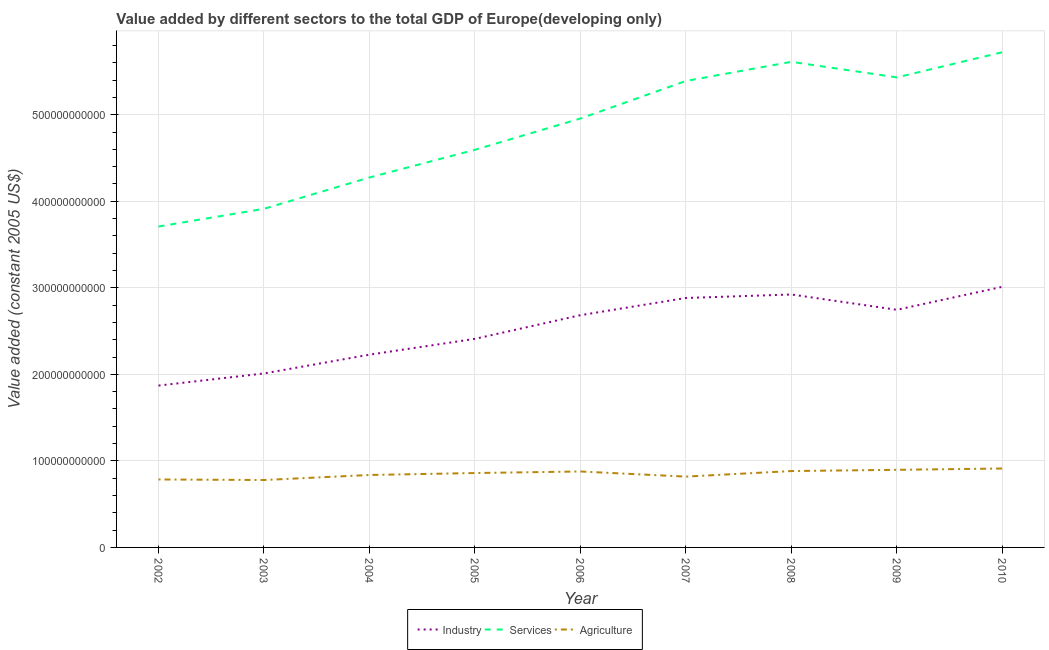How many different coloured lines are there?
Offer a terse response. 3. Is the number of lines equal to the number of legend labels?
Your answer should be compact. Yes. What is the value added by industrial sector in 2010?
Keep it short and to the point. 3.01e+11. Across all years, what is the maximum value added by agricultural sector?
Provide a short and direct response. 9.12e+1. Across all years, what is the minimum value added by services?
Your response must be concise. 3.71e+11. What is the total value added by services in the graph?
Offer a very short reply. 4.36e+12. What is the difference between the value added by industrial sector in 2006 and that in 2010?
Your answer should be compact. -3.28e+1. What is the difference between the value added by industrial sector in 2010 and the value added by services in 2007?
Make the answer very short. -2.38e+11. What is the average value added by agricultural sector per year?
Your response must be concise. 8.50e+1. In the year 2008, what is the difference between the value added by services and value added by agricultural sector?
Your answer should be very brief. 4.73e+11. What is the ratio of the value added by agricultural sector in 2008 to that in 2009?
Make the answer very short. 0.98. Is the difference between the value added by services in 2003 and 2009 greater than the difference between the value added by industrial sector in 2003 and 2009?
Your answer should be compact. No. What is the difference between the highest and the second highest value added by industrial sector?
Ensure brevity in your answer.  8.87e+09. What is the difference between the highest and the lowest value added by industrial sector?
Your answer should be very brief. 1.14e+11. In how many years, is the value added by industrial sector greater than the average value added by industrial sector taken over all years?
Give a very brief answer. 5. Is it the case that in every year, the sum of the value added by industrial sector and value added by services is greater than the value added by agricultural sector?
Give a very brief answer. Yes. Does the value added by services monotonically increase over the years?
Your answer should be compact. No. How many lines are there?
Ensure brevity in your answer.  3. How many years are there in the graph?
Keep it short and to the point. 9. What is the difference between two consecutive major ticks on the Y-axis?
Make the answer very short. 1.00e+11. Where does the legend appear in the graph?
Your answer should be very brief. Bottom center. What is the title of the graph?
Provide a succinct answer. Value added by different sectors to the total GDP of Europe(developing only). What is the label or title of the Y-axis?
Ensure brevity in your answer.  Value added (constant 2005 US$). What is the Value added (constant 2005 US$) of Industry in 2002?
Provide a succinct answer. 1.87e+11. What is the Value added (constant 2005 US$) of Services in 2002?
Keep it short and to the point. 3.71e+11. What is the Value added (constant 2005 US$) in Agriculture in 2002?
Provide a succinct answer. 7.85e+1. What is the Value added (constant 2005 US$) of Industry in 2003?
Your response must be concise. 2.01e+11. What is the Value added (constant 2005 US$) of Services in 2003?
Ensure brevity in your answer.  3.91e+11. What is the Value added (constant 2005 US$) in Agriculture in 2003?
Your answer should be compact. 7.79e+1. What is the Value added (constant 2005 US$) of Industry in 2004?
Your response must be concise. 2.23e+11. What is the Value added (constant 2005 US$) in Services in 2004?
Give a very brief answer. 4.27e+11. What is the Value added (constant 2005 US$) of Agriculture in 2004?
Provide a short and direct response. 8.37e+1. What is the Value added (constant 2005 US$) of Industry in 2005?
Your response must be concise. 2.41e+11. What is the Value added (constant 2005 US$) of Services in 2005?
Provide a short and direct response. 4.59e+11. What is the Value added (constant 2005 US$) in Agriculture in 2005?
Provide a short and direct response. 8.59e+1. What is the Value added (constant 2005 US$) in Industry in 2006?
Ensure brevity in your answer.  2.68e+11. What is the Value added (constant 2005 US$) in Services in 2006?
Ensure brevity in your answer.  4.96e+11. What is the Value added (constant 2005 US$) of Agriculture in 2006?
Your answer should be compact. 8.78e+1. What is the Value added (constant 2005 US$) in Industry in 2007?
Offer a very short reply. 2.88e+11. What is the Value added (constant 2005 US$) in Services in 2007?
Keep it short and to the point. 5.39e+11. What is the Value added (constant 2005 US$) of Agriculture in 2007?
Make the answer very short. 8.18e+1. What is the Value added (constant 2005 US$) in Industry in 2008?
Provide a succinct answer. 2.92e+11. What is the Value added (constant 2005 US$) of Services in 2008?
Keep it short and to the point. 5.61e+11. What is the Value added (constant 2005 US$) of Agriculture in 2008?
Provide a short and direct response. 8.83e+1. What is the Value added (constant 2005 US$) in Industry in 2009?
Give a very brief answer. 2.75e+11. What is the Value added (constant 2005 US$) of Services in 2009?
Ensure brevity in your answer.  5.43e+11. What is the Value added (constant 2005 US$) of Agriculture in 2009?
Ensure brevity in your answer.  8.97e+1. What is the Value added (constant 2005 US$) in Industry in 2010?
Give a very brief answer. 3.01e+11. What is the Value added (constant 2005 US$) in Services in 2010?
Offer a very short reply. 5.72e+11. What is the Value added (constant 2005 US$) in Agriculture in 2010?
Keep it short and to the point. 9.12e+1. Across all years, what is the maximum Value added (constant 2005 US$) in Industry?
Offer a very short reply. 3.01e+11. Across all years, what is the maximum Value added (constant 2005 US$) of Services?
Keep it short and to the point. 5.72e+11. Across all years, what is the maximum Value added (constant 2005 US$) in Agriculture?
Offer a terse response. 9.12e+1. Across all years, what is the minimum Value added (constant 2005 US$) in Industry?
Give a very brief answer. 1.87e+11. Across all years, what is the minimum Value added (constant 2005 US$) in Services?
Provide a short and direct response. 3.71e+11. Across all years, what is the minimum Value added (constant 2005 US$) of Agriculture?
Offer a terse response. 7.79e+1. What is the total Value added (constant 2005 US$) in Industry in the graph?
Offer a very short reply. 2.28e+12. What is the total Value added (constant 2005 US$) of Services in the graph?
Your response must be concise. 4.36e+12. What is the total Value added (constant 2005 US$) in Agriculture in the graph?
Offer a terse response. 7.65e+11. What is the difference between the Value added (constant 2005 US$) in Industry in 2002 and that in 2003?
Ensure brevity in your answer.  -1.40e+1. What is the difference between the Value added (constant 2005 US$) of Services in 2002 and that in 2003?
Ensure brevity in your answer.  -2.05e+1. What is the difference between the Value added (constant 2005 US$) in Agriculture in 2002 and that in 2003?
Offer a terse response. 6.42e+08. What is the difference between the Value added (constant 2005 US$) of Industry in 2002 and that in 2004?
Your answer should be very brief. -3.57e+1. What is the difference between the Value added (constant 2005 US$) of Services in 2002 and that in 2004?
Make the answer very short. -5.67e+1. What is the difference between the Value added (constant 2005 US$) in Agriculture in 2002 and that in 2004?
Offer a very short reply. -5.18e+09. What is the difference between the Value added (constant 2005 US$) in Industry in 2002 and that in 2005?
Provide a short and direct response. -5.40e+1. What is the difference between the Value added (constant 2005 US$) in Services in 2002 and that in 2005?
Give a very brief answer. -8.86e+1. What is the difference between the Value added (constant 2005 US$) of Agriculture in 2002 and that in 2005?
Make the answer very short. -7.42e+09. What is the difference between the Value added (constant 2005 US$) in Industry in 2002 and that in 2006?
Keep it short and to the point. -8.13e+1. What is the difference between the Value added (constant 2005 US$) in Services in 2002 and that in 2006?
Make the answer very short. -1.25e+11. What is the difference between the Value added (constant 2005 US$) of Agriculture in 2002 and that in 2006?
Make the answer very short. -9.23e+09. What is the difference between the Value added (constant 2005 US$) of Industry in 2002 and that in 2007?
Provide a succinct answer. -1.01e+11. What is the difference between the Value added (constant 2005 US$) of Services in 2002 and that in 2007?
Your answer should be very brief. -1.68e+11. What is the difference between the Value added (constant 2005 US$) of Agriculture in 2002 and that in 2007?
Make the answer very short. -3.29e+09. What is the difference between the Value added (constant 2005 US$) in Industry in 2002 and that in 2008?
Make the answer very short. -1.05e+11. What is the difference between the Value added (constant 2005 US$) in Services in 2002 and that in 2008?
Provide a succinct answer. -1.90e+11. What is the difference between the Value added (constant 2005 US$) in Agriculture in 2002 and that in 2008?
Your answer should be compact. -9.73e+09. What is the difference between the Value added (constant 2005 US$) in Industry in 2002 and that in 2009?
Offer a very short reply. -8.76e+1. What is the difference between the Value added (constant 2005 US$) in Services in 2002 and that in 2009?
Make the answer very short. -1.72e+11. What is the difference between the Value added (constant 2005 US$) of Agriculture in 2002 and that in 2009?
Offer a very short reply. -1.11e+1. What is the difference between the Value added (constant 2005 US$) in Industry in 2002 and that in 2010?
Your answer should be very brief. -1.14e+11. What is the difference between the Value added (constant 2005 US$) in Services in 2002 and that in 2010?
Ensure brevity in your answer.  -2.01e+11. What is the difference between the Value added (constant 2005 US$) of Agriculture in 2002 and that in 2010?
Offer a terse response. -1.27e+1. What is the difference between the Value added (constant 2005 US$) of Industry in 2003 and that in 2004?
Make the answer very short. -2.17e+1. What is the difference between the Value added (constant 2005 US$) in Services in 2003 and that in 2004?
Offer a very short reply. -3.62e+1. What is the difference between the Value added (constant 2005 US$) in Agriculture in 2003 and that in 2004?
Provide a short and direct response. -5.82e+09. What is the difference between the Value added (constant 2005 US$) of Industry in 2003 and that in 2005?
Ensure brevity in your answer.  -4.00e+1. What is the difference between the Value added (constant 2005 US$) in Services in 2003 and that in 2005?
Offer a terse response. -6.82e+1. What is the difference between the Value added (constant 2005 US$) in Agriculture in 2003 and that in 2005?
Provide a succinct answer. -8.06e+09. What is the difference between the Value added (constant 2005 US$) of Industry in 2003 and that in 2006?
Your response must be concise. -6.73e+1. What is the difference between the Value added (constant 2005 US$) in Services in 2003 and that in 2006?
Provide a succinct answer. -1.04e+11. What is the difference between the Value added (constant 2005 US$) in Agriculture in 2003 and that in 2006?
Give a very brief answer. -9.87e+09. What is the difference between the Value added (constant 2005 US$) in Industry in 2003 and that in 2007?
Ensure brevity in your answer.  -8.72e+1. What is the difference between the Value added (constant 2005 US$) of Services in 2003 and that in 2007?
Your response must be concise. -1.48e+11. What is the difference between the Value added (constant 2005 US$) in Agriculture in 2003 and that in 2007?
Offer a terse response. -3.93e+09. What is the difference between the Value added (constant 2005 US$) in Industry in 2003 and that in 2008?
Ensure brevity in your answer.  -9.12e+1. What is the difference between the Value added (constant 2005 US$) of Services in 2003 and that in 2008?
Give a very brief answer. -1.70e+11. What is the difference between the Value added (constant 2005 US$) of Agriculture in 2003 and that in 2008?
Offer a very short reply. -1.04e+1. What is the difference between the Value added (constant 2005 US$) in Industry in 2003 and that in 2009?
Your answer should be very brief. -7.35e+1. What is the difference between the Value added (constant 2005 US$) of Services in 2003 and that in 2009?
Make the answer very short. -1.52e+11. What is the difference between the Value added (constant 2005 US$) in Agriculture in 2003 and that in 2009?
Give a very brief answer. -1.18e+1. What is the difference between the Value added (constant 2005 US$) of Industry in 2003 and that in 2010?
Offer a very short reply. -1.00e+11. What is the difference between the Value added (constant 2005 US$) of Services in 2003 and that in 2010?
Ensure brevity in your answer.  -1.81e+11. What is the difference between the Value added (constant 2005 US$) in Agriculture in 2003 and that in 2010?
Offer a very short reply. -1.33e+1. What is the difference between the Value added (constant 2005 US$) in Industry in 2004 and that in 2005?
Give a very brief answer. -1.83e+1. What is the difference between the Value added (constant 2005 US$) in Services in 2004 and that in 2005?
Your response must be concise. -3.20e+1. What is the difference between the Value added (constant 2005 US$) in Agriculture in 2004 and that in 2005?
Provide a short and direct response. -2.24e+09. What is the difference between the Value added (constant 2005 US$) of Industry in 2004 and that in 2006?
Give a very brief answer. -4.56e+1. What is the difference between the Value added (constant 2005 US$) in Services in 2004 and that in 2006?
Your answer should be very brief. -6.81e+1. What is the difference between the Value added (constant 2005 US$) in Agriculture in 2004 and that in 2006?
Make the answer very short. -4.05e+09. What is the difference between the Value added (constant 2005 US$) of Industry in 2004 and that in 2007?
Your response must be concise. -6.55e+1. What is the difference between the Value added (constant 2005 US$) in Services in 2004 and that in 2007?
Give a very brief answer. -1.12e+11. What is the difference between the Value added (constant 2005 US$) in Agriculture in 2004 and that in 2007?
Provide a succinct answer. 1.89e+09. What is the difference between the Value added (constant 2005 US$) of Industry in 2004 and that in 2008?
Your answer should be very brief. -6.95e+1. What is the difference between the Value added (constant 2005 US$) in Services in 2004 and that in 2008?
Give a very brief answer. -1.34e+11. What is the difference between the Value added (constant 2005 US$) in Agriculture in 2004 and that in 2008?
Keep it short and to the point. -4.55e+09. What is the difference between the Value added (constant 2005 US$) of Industry in 2004 and that in 2009?
Offer a terse response. -5.18e+1. What is the difference between the Value added (constant 2005 US$) in Services in 2004 and that in 2009?
Provide a short and direct response. -1.16e+11. What is the difference between the Value added (constant 2005 US$) in Agriculture in 2004 and that in 2009?
Provide a succinct answer. -5.96e+09. What is the difference between the Value added (constant 2005 US$) in Industry in 2004 and that in 2010?
Ensure brevity in your answer.  -7.84e+1. What is the difference between the Value added (constant 2005 US$) in Services in 2004 and that in 2010?
Provide a short and direct response. -1.45e+11. What is the difference between the Value added (constant 2005 US$) in Agriculture in 2004 and that in 2010?
Keep it short and to the point. -7.50e+09. What is the difference between the Value added (constant 2005 US$) in Industry in 2005 and that in 2006?
Your answer should be very brief. -2.74e+1. What is the difference between the Value added (constant 2005 US$) of Services in 2005 and that in 2006?
Your answer should be compact. -3.62e+1. What is the difference between the Value added (constant 2005 US$) of Agriculture in 2005 and that in 2006?
Your response must be concise. -1.81e+09. What is the difference between the Value added (constant 2005 US$) of Industry in 2005 and that in 2007?
Give a very brief answer. -4.72e+1. What is the difference between the Value added (constant 2005 US$) in Services in 2005 and that in 2007?
Offer a terse response. -7.96e+1. What is the difference between the Value added (constant 2005 US$) of Agriculture in 2005 and that in 2007?
Make the answer very short. 4.13e+09. What is the difference between the Value added (constant 2005 US$) of Industry in 2005 and that in 2008?
Ensure brevity in your answer.  -5.13e+1. What is the difference between the Value added (constant 2005 US$) of Services in 2005 and that in 2008?
Provide a succinct answer. -1.02e+11. What is the difference between the Value added (constant 2005 US$) of Agriculture in 2005 and that in 2008?
Make the answer very short. -2.30e+09. What is the difference between the Value added (constant 2005 US$) of Industry in 2005 and that in 2009?
Give a very brief answer. -3.36e+1. What is the difference between the Value added (constant 2005 US$) in Services in 2005 and that in 2009?
Offer a terse response. -8.37e+1. What is the difference between the Value added (constant 2005 US$) of Agriculture in 2005 and that in 2009?
Provide a short and direct response. -3.72e+09. What is the difference between the Value added (constant 2005 US$) in Industry in 2005 and that in 2010?
Keep it short and to the point. -6.01e+1. What is the difference between the Value added (constant 2005 US$) of Services in 2005 and that in 2010?
Provide a succinct answer. -1.13e+11. What is the difference between the Value added (constant 2005 US$) of Agriculture in 2005 and that in 2010?
Offer a terse response. -5.25e+09. What is the difference between the Value added (constant 2005 US$) in Industry in 2006 and that in 2007?
Ensure brevity in your answer.  -1.99e+1. What is the difference between the Value added (constant 2005 US$) of Services in 2006 and that in 2007?
Provide a succinct answer. -4.34e+1. What is the difference between the Value added (constant 2005 US$) in Agriculture in 2006 and that in 2007?
Your response must be concise. 5.94e+09. What is the difference between the Value added (constant 2005 US$) in Industry in 2006 and that in 2008?
Your answer should be compact. -2.39e+1. What is the difference between the Value added (constant 2005 US$) in Services in 2006 and that in 2008?
Give a very brief answer. -6.55e+1. What is the difference between the Value added (constant 2005 US$) in Agriculture in 2006 and that in 2008?
Offer a terse response. -4.99e+08. What is the difference between the Value added (constant 2005 US$) of Industry in 2006 and that in 2009?
Your response must be concise. -6.21e+09. What is the difference between the Value added (constant 2005 US$) of Services in 2006 and that in 2009?
Give a very brief answer. -4.75e+1. What is the difference between the Value added (constant 2005 US$) in Agriculture in 2006 and that in 2009?
Give a very brief answer. -1.91e+09. What is the difference between the Value added (constant 2005 US$) of Industry in 2006 and that in 2010?
Provide a short and direct response. -3.28e+1. What is the difference between the Value added (constant 2005 US$) in Services in 2006 and that in 2010?
Your response must be concise. -7.66e+1. What is the difference between the Value added (constant 2005 US$) of Agriculture in 2006 and that in 2010?
Provide a succinct answer. -3.45e+09. What is the difference between the Value added (constant 2005 US$) in Industry in 2007 and that in 2008?
Ensure brevity in your answer.  -4.03e+09. What is the difference between the Value added (constant 2005 US$) in Services in 2007 and that in 2008?
Make the answer very short. -2.21e+1. What is the difference between the Value added (constant 2005 US$) of Agriculture in 2007 and that in 2008?
Keep it short and to the point. -6.43e+09. What is the difference between the Value added (constant 2005 US$) of Industry in 2007 and that in 2009?
Ensure brevity in your answer.  1.37e+1. What is the difference between the Value added (constant 2005 US$) in Services in 2007 and that in 2009?
Make the answer very short. -4.13e+09. What is the difference between the Value added (constant 2005 US$) of Agriculture in 2007 and that in 2009?
Offer a terse response. -7.85e+09. What is the difference between the Value added (constant 2005 US$) in Industry in 2007 and that in 2010?
Offer a very short reply. -1.29e+1. What is the difference between the Value added (constant 2005 US$) in Services in 2007 and that in 2010?
Offer a terse response. -3.32e+1. What is the difference between the Value added (constant 2005 US$) of Agriculture in 2007 and that in 2010?
Provide a short and direct response. -9.39e+09. What is the difference between the Value added (constant 2005 US$) of Industry in 2008 and that in 2009?
Your answer should be very brief. 1.77e+1. What is the difference between the Value added (constant 2005 US$) in Services in 2008 and that in 2009?
Offer a very short reply. 1.80e+1. What is the difference between the Value added (constant 2005 US$) of Agriculture in 2008 and that in 2009?
Provide a succinct answer. -1.41e+09. What is the difference between the Value added (constant 2005 US$) in Industry in 2008 and that in 2010?
Your answer should be compact. -8.87e+09. What is the difference between the Value added (constant 2005 US$) of Services in 2008 and that in 2010?
Provide a short and direct response. -1.11e+1. What is the difference between the Value added (constant 2005 US$) in Agriculture in 2008 and that in 2010?
Make the answer very short. -2.95e+09. What is the difference between the Value added (constant 2005 US$) of Industry in 2009 and that in 2010?
Give a very brief answer. -2.66e+1. What is the difference between the Value added (constant 2005 US$) in Services in 2009 and that in 2010?
Your answer should be compact. -2.91e+1. What is the difference between the Value added (constant 2005 US$) in Agriculture in 2009 and that in 2010?
Make the answer very short. -1.54e+09. What is the difference between the Value added (constant 2005 US$) in Industry in 2002 and the Value added (constant 2005 US$) in Services in 2003?
Give a very brief answer. -2.04e+11. What is the difference between the Value added (constant 2005 US$) in Industry in 2002 and the Value added (constant 2005 US$) in Agriculture in 2003?
Offer a very short reply. 1.09e+11. What is the difference between the Value added (constant 2005 US$) of Services in 2002 and the Value added (constant 2005 US$) of Agriculture in 2003?
Offer a terse response. 2.93e+11. What is the difference between the Value added (constant 2005 US$) of Industry in 2002 and the Value added (constant 2005 US$) of Services in 2004?
Offer a very short reply. -2.40e+11. What is the difference between the Value added (constant 2005 US$) of Industry in 2002 and the Value added (constant 2005 US$) of Agriculture in 2004?
Your response must be concise. 1.03e+11. What is the difference between the Value added (constant 2005 US$) in Services in 2002 and the Value added (constant 2005 US$) in Agriculture in 2004?
Ensure brevity in your answer.  2.87e+11. What is the difference between the Value added (constant 2005 US$) in Industry in 2002 and the Value added (constant 2005 US$) in Services in 2005?
Your answer should be very brief. -2.72e+11. What is the difference between the Value added (constant 2005 US$) in Industry in 2002 and the Value added (constant 2005 US$) in Agriculture in 2005?
Provide a succinct answer. 1.01e+11. What is the difference between the Value added (constant 2005 US$) of Services in 2002 and the Value added (constant 2005 US$) of Agriculture in 2005?
Provide a short and direct response. 2.85e+11. What is the difference between the Value added (constant 2005 US$) in Industry in 2002 and the Value added (constant 2005 US$) in Services in 2006?
Make the answer very short. -3.09e+11. What is the difference between the Value added (constant 2005 US$) in Industry in 2002 and the Value added (constant 2005 US$) in Agriculture in 2006?
Provide a short and direct response. 9.93e+1. What is the difference between the Value added (constant 2005 US$) of Services in 2002 and the Value added (constant 2005 US$) of Agriculture in 2006?
Offer a terse response. 2.83e+11. What is the difference between the Value added (constant 2005 US$) in Industry in 2002 and the Value added (constant 2005 US$) in Services in 2007?
Provide a succinct answer. -3.52e+11. What is the difference between the Value added (constant 2005 US$) in Industry in 2002 and the Value added (constant 2005 US$) in Agriculture in 2007?
Provide a short and direct response. 1.05e+11. What is the difference between the Value added (constant 2005 US$) of Services in 2002 and the Value added (constant 2005 US$) of Agriculture in 2007?
Ensure brevity in your answer.  2.89e+11. What is the difference between the Value added (constant 2005 US$) of Industry in 2002 and the Value added (constant 2005 US$) of Services in 2008?
Keep it short and to the point. -3.74e+11. What is the difference between the Value added (constant 2005 US$) in Industry in 2002 and the Value added (constant 2005 US$) in Agriculture in 2008?
Keep it short and to the point. 9.88e+1. What is the difference between the Value added (constant 2005 US$) of Services in 2002 and the Value added (constant 2005 US$) of Agriculture in 2008?
Offer a terse response. 2.83e+11. What is the difference between the Value added (constant 2005 US$) in Industry in 2002 and the Value added (constant 2005 US$) in Services in 2009?
Give a very brief answer. -3.56e+11. What is the difference between the Value added (constant 2005 US$) of Industry in 2002 and the Value added (constant 2005 US$) of Agriculture in 2009?
Provide a short and direct response. 9.74e+1. What is the difference between the Value added (constant 2005 US$) in Services in 2002 and the Value added (constant 2005 US$) in Agriculture in 2009?
Your answer should be compact. 2.81e+11. What is the difference between the Value added (constant 2005 US$) in Industry in 2002 and the Value added (constant 2005 US$) in Services in 2010?
Make the answer very short. -3.85e+11. What is the difference between the Value added (constant 2005 US$) in Industry in 2002 and the Value added (constant 2005 US$) in Agriculture in 2010?
Your response must be concise. 9.58e+1. What is the difference between the Value added (constant 2005 US$) in Services in 2002 and the Value added (constant 2005 US$) in Agriculture in 2010?
Ensure brevity in your answer.  2.80e+11. What is the difference between the Value added (constant 2005 US$) in Industry in 2003 and the Value added (constant 2005 US$) in Services in 2004?
Your answer should be compact. -2.26e+11. What is the difference between the Value added (constant 2005 US$) in Industry in 2003 and the Value added (constant 2005 US$) in Agriculture in 2004?
Your answer should be very brief. 1.17e+11. What is the difference between the Value added (constant 2005 US$) of Services in 2003 and the Value added (constant 2005 US$) of Agriculture in 2004?
Provide a short and direct response. 3.08e+11. What is the difference between the Value added (constant 2005 US$) of Industry in 2003 and the Value added (constant 2005 US$) of Services in 2005?
Make the answer very short. -2.58e+11. What is the difference between the Value added (constant 2005 US$) in Industry in 2003 and the Value added (constant 2005 US$) in Agriculture in 2005?
Offer a very short reply. 1.15e+11. What is the difference between the Value added (constant 2005 US$) of Services in 2003 and the Value added (constant 2005 US$) of Agriculture in 2005?
Ensure brevity in your answer.  3.05e+11. What is the difference between the Value added (constant 2005 US$) of Industry in 2003 and the Value added (constant 2005 US$) of Services in 2006?
Provide a succinct answer. -2.95e+11. What is the difference between the Value added (constant 2005 US$) of Industry in 2003 and the Value added (constant 2005 US$) of Agriculture in 2006?
Your answer should be very brief. 1.13e+11. What is the difference between the Value added (constant 2005 US$) of Services in 2003 and the Value added (constant 2005 US$) of Agriculture in 2006?
Give a very brief answer. 3.04e+11. What is the difference between the Value added (constant 2005 US$) of Industry in 2003 and the Value added (constant 2005 US$) of Services in 2007?
Give a very brief answer. -3.38e+11. What is the difference between the Value added (constant 2005 US$) in Industry in 2003 and the Value added (constant 2005 US$) in Agriculture in 2007?
Your response must be concise. 1.19e+11. What is the difference between the Value added (constant 2005 US$) of Services in 2003 and the Value added (constant 2005 US$) of Agriculture in 2007?
Make the answer very short. 3.09e+11. What is the difference between the Value added (constant 2005 US$) in Industry in 2003 and the Value added (constant 2005 US$) in Services in 2008?
Provide a short and direct response. -3.60e+11. What is the difference between the Value added (constant 2005 US$) in Industry in 2003 and the Value added (constant 2005 US$) in Agriculture in 2008?
Ensure brevity in your answer.  1.13e+11. What is the difference between the Value added (constant 2005 US$) in Services in 2003 and the Value added (constant 2005 US$) in Agriculture in 2008?
Keep it short and to the point. 3.03e+11. What is the difference between the Value added (constant 2005 US$) of Industry in 2003 and the Value added (constant 2005 US$) of Services in 2009?
Keep it short and to the point. -3.42e+11. What is the difference between the Value added (constant 2005 US$) in Industry in 2003 and the Value added (constant 2005 US$) in Agriculture in 2009?
Provide a short and direct response. 1.11e+11. What is the difference between the Value added (constant 2005 US$) of Services in 2003 and the Value added (constant 2005 US$) of Agriculture in 2009?
Give a very brief answer. 3.02e+11. What is the difference between the Value added (constant 2005 US$) in Industry in 2003 and the Value added (constant 2005 US$) in Services in 2010?
Make the answer very short. -3.71e+11. What is the difference between the Value added (constant 2005 US$) in Industry in 2003 and the Value added (constant 2005 US$) in Agriculture in 2010?
Ensure brevity in your answer.  1.10e+11. What is the difference between the Value added (constant 2005 US$) in Services in 2003 and the Value added (constant 2005 US$) in Agriculture in 2010?
Your answer should be compact. 3.00e+11. What is the difference between the Value added (constant 2005 US$) in Industry in 2004 and the Value added (constant 2005 US$) in Services in 2005?
Ensure brevity in your answer.  -2.37e+11. What is the difference between the Value added (constant 2005 US$) in Industry in 2004 and the Value added (constant 2005 US$) in Agriculture in 2005?
Offer a terse response. 1.37e+11. What is the difference between the Value added (constant 2005 US$) in Services in 2004 and the Value added (constant 2005 US$) in Agriculture in 2005?
Offer a very short reply. 3.42e+11. What is the difference between the Value added (constant 2005 US$) of Industry in 2004 and the Value added (constant 2005 US$) of Services in 2006?
Your response must be concise. -2.73e+11. What is the difference between the Value added (constant 2005 US$) of Industry in 2004 and the Value added (constant 2005 US$) of Agriculture in 2006?
Provide a short and direct response. 1.35e+11. What is the difference between the Value added (constant 2005 US$) in Services in 2004 and the Value added (constant 2005 US$) in Agriculture in 2006?
Your answer should be compact. 3.40e+11. What is the difference between the Value added (constant 2005 US$) of Industry in 2004 and the Value added (constant 2005 US$) of Services in 2007?
Offer a terse response. -3.16e+11. What is the difference between the Value added (constant 2005 US$) in Industry in 2004 and the Value added (constant 2005 US$) in Agriculture in 2007?
Keep it short and to the point. 1.41e+11. What is the difference between the Value added (constant 2005 US$) in Services in 2004 and the Value added (constant 2005 US$) in Agriculture in 2007?
Provide a short and direct response. 3.46e+11. What is the difference between the Value added (constant 2005 US$) in Industry in 2004 and the Value added (constant 2005 US$) in Services in 2008?
Offer a terse response. -3.38e+11. What is the difference between the Value added (constant 2005 US$) of Industry in 2004 and the Value added (constant 2005 US$) of Agriculture in 2008?
Provide a succinct answer. 1.34e+11. What is the difference between the Value added (constant 2005 US$) of Services in 2004 and the Value added (constant 2005 US$) of Agriculture in 2008?
Make the answer very short. 3.39e+11. What is the difference between the Value added (constant 2005 US$) of Industry in 2004 and the Value added (constant 2005 US$) of Services in 2009?
Ensure brevity in your answer.  -3.20e+11. What is the difference between the Value added (constant 2005 US$) of Industry in 2004 and the Value added (constant 2005 US$) of Agriculture in 2009?
Provide a short and direct response. 1.33e+11. What is the difference between the Value added (constant 2005 US$) of Services in 2004 and the Value added (constant 2005 US$) of Agriculture in 2009?
Offer a very short reply. 3.38e+11. What is the difference between the Value added (constant 2005 US$) of Industry in 2004 and the Value added (constant 2005 US$) of Services in 2010?
Make the answer very short. -3.49e+11. What is the difference between the Value added (constant 2005 US$) of Industry in 2004 and the Value added (constant 2005 US$) of Agriculture in 2010?
Offer a very short reply. 1.32e+11. What is the difference between the Value added (constant 2005 US$) of Services in 2004 and the Value added (constant 2005 US$) of Agriculture in 2010?
Keep it short and to the point. 3.36e+11. What is the difference between the Value added (constant 2005 US$) of Industry in 2005 and the Value added (constant 2005 US$) of Services in 2006?
Offer a very short reply. -2.55e+11. What is the difference between the Value added (constant 2005 US$) of Industry in 2005 and the Value added (constant 2005 US$) of Agriculture in 2006?
Provide a succinct answer. 1.53e+11. What is the difference between the Value added (constant 2005 US$) of Services in 2005 and the Value added (constant 2005 US$) of Agriculture in 2006?
Provide a succinct answer. 3.72e+11. What is the difference between the Value added (constant 2005 US$) of Industry in 2005 and the Value added (constant 2005 US$) of Services in 2007?
Your answer should be very brief. -2.98e+11. What is the difference between the Value added (constant 2005 US$) in Industry in 2005 and the Value added (constant 2005 US$) in Agriculture in 2007?
Provide a succinct answer. 1.59e+11. What is the difference between the Value added (constant 2005 US$) in Services in 2005 and the Value added (constant 2005 US$) in Agriculture in 2007?
Make the answer very short. 3.78e+11. What is the difference between the Value added (constant 2005 US$) in Industry in 2005 and the Value added (constant 2005 US$) in Services in 2008?
Your answer should be compact. -3.20e+11. What is the difference between the Value added (constant 2005 US$) in Industry in 2005 and the Value added (constant 2005 US$) in Agriculture in 2008?
Your answer should be very brief. 1.53e+11. What is the difference between the Value added (constant 2005 US$) in Services in 2005 and the Value added (constant 2005 US$) in Agriculture in 2008?
Provide a succinct answer. 3.71e+11. What is the difference between the Value added (constant 2005 US$) in Industry in 2005 and the Value added (constant 2005 US$) in Services in 2009?
Provide a succinct answer. -3.02e+11. What is the difference between the Value added (constant 2005 US$) of Industry in 2005 and the Value added (constant 2005 US$) of Agriculture in 2009?
Offer a very short reply. 1.51e+11. What is the difference between the Value added (constant 2005 US$) in Services in 2005 and the Value added (constant 2005 US$) in Agriculture in 2009?
Your answer should be very brief. 3.70e+11. What is the difference between the Value added (constant 2005 US$) in Industry in 2005 and the Value added (constant 2005 US$) in Services in 2010?
Offer a very short reply. -3.31e+11. What is the difference between the Value added (constant 2005 US$) in Industry in 2005 and the Value added (constant 2005 US$) in Agriculture in 2010?
Your answer should be very brief. 1.50e+11. What is the difference between the Value added (constant 2005 US$) of Services in 2005 and the Value added (constant 2005 US$) of Agriculture in 2010?
Offer a very short reply. 3.68e+11. What is the difference between the Value added (constant 2005 US$) in Industry in 2006 and the Value added (constant 2005 US$) in Services in 2007?
Your response must be concise. -2.71e+11. What is the difference between the Value added (constant 2005 US$) of Industry in 2006 and the Value added (constant 2005 US$) of Agriculture in 2007?
Your answer should be very brief. 1.87e+11. What is the difference between the Value added (constant 2005 US$) in Services in 2006 and the Value added (constant 2005 US$) in Agriculture in 2007?
Keep it short and to the point. 4.14e+11. What is the difference between the Value added (constant 2005 US$) in Industry in 2006 and the Value added (constant 2005 US$) in Services in 2008?
Provide a short and direct response. -2.93e+11. What is the difference between the Value added (constant 2005 US$) of Industry in 2006 and the Value added (constant 2005 US$) of Agriculture in 2008?
Your answer should be compact. 1.80e+11. What is the difference between the Value added (constant 2005 US$) in Services in 2006 and the Value added (constant 2005 US$) in Agriculture in 2008?
Your answer should be very brief. 4.07e+11. What is the difference between the Value added (constant 2005 US$) in Industry in 2006 and the Value added (constant 2005 US$) in Services in 2009?
Provide a short and direct response. -2.75e+11. What is the difference between the Value added (constant 2005 US$) of Industry in 2006 and the Value added (constant 2005 US$) of Agriculture in 2009?
Offer a very short reply. 1.79e+11. What is the difference between the Value added (constant 2005 US$) of Services in 2006 and the Value added (constant 2005 US$) of Agriculture in 2009?
Keep it short and to the point. 4.06e+11. What is the difference between the Value added (constant 2005 US$) in Industry in 2006 and the Value added (constant 2005 US$) in Services in 2010?
Ensure brevity in your answer.  -3.04e+11. What is the difference between the Value added (constant 2005 US$) in Industry in 2006 and the Value added (constant 2005 US$) in Agriculture in 2010?
Provide a short and direct response. 1.77e+11. What is the difference between the Value added (constant 2005 US$) in Services in 2006 and the Value added (constant 2005 US$) in Agriculture in 2010?
Provide a succinct answer. 4.04e+11. What is the difference between the Value added (constant 2005 US$) in Industry in 2007 and the Value added (constant 2005 US$) in Services in 2008?
Your answer should be very brief. -2.73e+11. What is the difference between the Value added (constant 2005 US$) of Industry in 2007 and the Value added (constant 2005 US$) of Agriculture in 2008?
Offer a terse response. 2.00e+11. What is the difference between the Value added (constant 2005 US$) in Services in 2007 and the Value added (constant 2005 US$) in Agriculture in 2008?
Ensure brevity in your answer.  4.51e+11. What is the difference between the Value added (constant 2005 US$) in Industry in 2007 and the Value added (constant 2005 US$) in Services in 2009?
Your answer should be very brief. -2.55e+11. What is the difference between the Value added (constant 2005 US$) in Industry in 2007 and the Value added (constant 2005 US$) in Agriculture in 2009?
Your answer should be very brief. 1.99e+11. What is the difference between the Value added (constant 2005 US$) in Services in 2007 and the Value added (constant 2005 US$) in Agriculture in 2009?
Give a very brief answer. 4.49e+11. What is the difference between the Value added (constant 2005 US$) of Industry in 2007 and the Value added (constant 2005 US$) of Services in 2010?
Offer a very short reply. -2.84e+11. What is the difference between the Value added (constant 2005 US$) of Industry in 2007 and the Value added (constant 2005 US$) of Agriculture in 2010?
Keep it short and to the point. 1.97e+11. What is the difference between the Value added (constant 2005 US$) in Services in 2007 and the Value added (constant 2005 US$) in Agriculture in 2010?
Offer a very short reply. 4.48e+11. What is the difference between the Value added (constant 2005 US$) of Industry in 2008 and the Value added (constant 2005 US$) of Services in 2009?
Your answer should be compact. -2.51e+11. What is the difference between the Value added (constant 2005 US$) in Industry in 2008 and the Value added (constant 2005 US$) in Agriculture in 2009?
Your response must be concise. 2.03e+11. What is the difference between the Value added (constant 2005 US$) of Services in 2008 and the Value added (constant 2005 US$) of Agriculture in 2009?
Make the answer very short. 4.71e+11. What is the difference between the Value added (constant 2005 US$) of Industry in 2008 and the Value added (constant 2005 US$) of Services in 2010?
Make the answer very short. -2.80e+11. What is the difference between the Value added (constant 2005 US$) of Industry in 2008 and the Value added (constant 2005 US$) of Agriculture in 2010?
Make the answer very short. 2.01e+11. What is the difference between the Value added (constant 2005 US$) in Services in 2008 and the Value added (constant 2005 US$) in Agriculture in 2010?
Your answer should be very brief. 4.70e+11. What is the difference between the Value added (constant 2005 US$) of Industry in 2009 and the Value added (constant 2005 US$) of Services in 2010?
Ensure brevity in your answer.  -2.98e+11. What is the difference between the Value added (constant 2005 US$) of Industry in 2009 and the Value added (constant 2005 US$) of Agriculture in 2010?
Offer a terse response. 1.83e+11. What is the difference between the Value added (constant 2005 US$) of Services in 2009 and the Value added (constant 2005 US$) of Agriculture in 2010?
Your answer should be very brief. 4.52e+11. What is the average Value added (constant 2005 US$) in Industry per year?
Make the answer very short. 2.53e+11. What is the average Value added (constant 2005 US$) in Services per year?
Give a very brief answer. 4.84e+11. What is the average Value added (constant 2005 US$) of Agriculture per year?
Keep it short and to the point. 8.50e+1. In the year 2002, what is the difference between the Value added (constant 2005 US$) in Industry and Value added (constant 2005 US$) in Services?
Keep it short and to the point. -1.84e+11. In the year 2002, what is the difference between the Value added (constant 2005 US$) of Industry and Value added (constant 2005 US$) of Agriculture?
Your answer should be very brief. 1.08e+11. In the year 2002, what is the difference between the Value added (constant 2005 US$) in Services and Value added (constant 2005 US$) in Agriculture?
Make the answer very short. 2.92e+11. In the year 2003, what is the difference between the Value added (constant 2005 US$) in Industry and Value added (constant 2005 US$) in Services?
Your answer should be compact. -1.90e+11. In the year 2003, what is the difference between the Value added (constant 2005 US$) in Industry and Value added (constant 2005 US$) in Agriculture?
Make the answer very short. 1.23e+11. In the year 2003, what is the difference between the Value added (constant 2005 US$) in Services and Value added (constant 2005 US$) in Agriculture?
Offer a very short reply. 3.13e+11. In the year 2004, what is the difference between the Value added (constant 2005 US$) of Industry and Value added (constant 2005 US$) of Services?
Give a very brief answer. -2.05e+11. In the year 2004, what is the difference between the Value added (constant 2005 US$) in Industry and Value added (constant 2005 US$) in Agriculture?
Your answer should be very brief. 1.39e+11. In the year 2004, what is the difference between the Value added (constant 2005 US$) of Services and Value added (constant 2005 US$) of Agriculture?
Give a very brief answer. 3.44e+11. In the year 2005, what is the difference between the Value added (constant 2005 US$) in Industry and Value added (constant 2005 US$) in Services?
Provide a succinct answer. -2.18e+11. In the year 2005, what is the difference between the Value added (constant 2005 US$) of Industry and Value added (constant 2005 US$) of Agriculture?
Your response must be concise. 1.55e+11. In the year 2005, what is the difference between the Value added (constant 2005 US$) of Services and Value added (constant 2005 US$) of Agriculture?
Offer a terse response. 3.73e+11. In the year 2006, what is the difference between the Value added (constant 2005 US$) in Industry and Value added (constant 2005 US$) in Services?
Your response must be concise. -2.27e+11. In the year 2006, what is the difference between the Value added (constant 2005 US$) of Industry and Value added (constant 2005 US$) of Agriculture?
Offer a terse response. 1.81e+11. In the year 2006, what is the difference between the Value added (constant 2005 US$) of Services and Value added (constant 2005 US$) of Agriculture?
Your answer should be compact. 4.08e+11. In the year 2007, what is the difference between the Value added (constant 2005 US$) of Industry and Value added (constant 2005 US$) of Services?
Your answer should be very brief. -2.51e+11. In the year 2007, what is the difference between the Value added (constant 2005 US$) in Industry and Value added (constant 2005 US$) in Agriculture?
Give a very brief answer. 2.06e+11. In the year 2007, what is the difference between the Value added (constant 2005 US$) in Services and Value added (constant 2005 US$) in Agriculture?
Offer a terse response. 4.57e+11. In the year 2008, what is the difference between the Value added (constant 2005 US$) of Industry and Value added (constant 2005 US$) of Services?
Make the answer very short. -2.69e+11. In the year 2008, what is the difference between the Value added (constant 2005 US$) in Industry and Value added (constant 2005 US$) in Agriculture?
Your answer should be compact. 2.04e+11. In the year 2008, what is the difference between the Value added (constant 2005 US$) in Services and Value added (constant 2005 US$) in Agriculture?
Provide a short and direct response. 4.73e+11. In the year 2009, what is the difference between the Value added (constant 2005 US$) of Industry and Value added (constant 2005 US$) of Services?
Your response must be concise. -2.69e+11. In the year 2009, what is the difference between the Value added (constant 2005 US$) in Industry and Value added (constant 2005 US$) in Agriculture?
Your answer should be very brief. 1.85e+11. In the year 2009, what is the difference between the Value added (constant 2005 US$) in Services and Value added (constant 2005 US$) in Agriculture?
Offer a very short reply. 4.53e+11. In the year 2010, what is the difference between the Value added (constant 2005 US$) in Industry and Value added (constant 2005 US$) in Services?
Offer a very short reply. -2.71e+11. In the year 2010, what is the difference between the Value added (constant 2005 US$) in Industry and Value added (constant 2005 US$) in Agriculture?
Give a very brief answer. 2.10e+11. In the year 2010, what is the difference between the Value added (constant 2005 US$) of Services and Value added (constant 2005 US$) of Agriculture?
Offer a terse response. 4.81e+11. What is the ratio of the Value added (constant 2005 US$) in Industry in 2002 to that in 2003?
Provide a short and direct response. 0.93. What is the ratio of the Value added (constant 2005 US$) of Services in 2002 to that in 2003?
Your response must be concise. 0.95. What is the ratio of the Value added (constant 2005 US$) in Agriculture in 2002 to that in 2003?
Offer a very short reply. 1.01. What is the ratio of the Value added (constant 2005 US$) of Industry in 2002 to that in 2004?
Ensure brevity in your answer.  0.84. What is the ratio of the Value added (constant 2005 US$) of Services in 2002 to that in 2004?
Provide a short and direct response. 0.87. What is the ratio of the Value added (constant 2005 US$) of Agriculture in 2002 to that in 2004?
Offer a very short reply. 0.94. What is the ratio of the Value added (constant 2005 US$) of Industry in 2002 to that in 2005?
Your response must be concise. 0.78. What is the ratio of the Value added (constant 2005 US$) in Services in 2002 to that in 2005?
Your answer should be very brief. 0.81. What is the ratio of the Value added (constant 2005 US$) of Agriculture in 2002 to that in 2005?
Make the answer very short. 0.91. What is the ratio of the Value added (constant 2005 US$) in Industry in 2002 to that in 2006?
Your answer should be very brief. 0.7. What is the ratio of the Value added (constant 2005 US$) in Services in 2002 to that in 2006?
Provide a short and direct response. 0.75. What is the ratio of the Value added (constant 2005 US$) in Agriculture in 2002 to that in 2006?
Your answer should be very brief. 0.89. What is the ratio of the Value added (constant 2005 US$) of Industry in 2002 to that in 2007?
Make the answer very short. 0.65. What is the ratio of the Value added (constant 2005 US$) in Services in 2002 to that in 2007?
Provide a succinct answer. 0.69. What is the ratio of the Value added (constant 2005 US$) in Agriculture in 2002 to that in 2007?
Offer a very short reply. 0.96. What is the ratio of the Value added (constant 2005 US$) of Industry in 2002 to that in 2008?
Your answer should be compact. 0.64. What is the ratio of the Value added (constant 2005 US$) in Services in 2002 to that in 2008?
Your answer should be compact. 0.66. What is the ratio of the Value added (constant 2005 US$) of Agriculture in 2002 to that in 2008?
Keep it short and to the point. 0.89. What is the ratio of the Value added (constant 2005 US$) in Industry in 2002 to that in 2009?
Give a very brief answer. 0.68. What is the ratio of the Value added (constant 2005 US$) in Services in 2002 to that in 2009?
Ensure brevity in your answer.  0.68. What is the ratio of the Value added (constant 2005 US$) of Agriculture in 2002 to that in 2009?
Provide a short and direct response. 0.88. What is the ratio of the Value added (constant 2005 US$) of Industry in 2002 to that in 2010?
Provide a short and direct response. 0.62. What is the ratio of the Value added (constant 2005 US$) of Services in 2002 to that in 2010?
Keep it short and to the point. 0.65. What is the ratio of the Value added (constant 2005 US$) of Agriculture in 2002 to that in 2010?
Your answer should be compact. 0.86. What is the ratio of the Value added (constant 2005 US$) of Industry in 2003 to that in 2004?
Provide a short and direct response. 0.9. What is the ratio of the Value added (constant 2005 US$) of Services in 2003 to that in 2004?
Your answer should be very brief. 0.92. What is the ratio of the Value added (constant 2005 US$) in Agriculture in 2003 to that in 2004?
Provide a succinct answer. 0.93. What is the ratio of the Value added (constant 2005 US$) in Industry in 2003 to that in 2005?
Ensure brevity in your answer.  0.83. What is the ratio of the Value added (constant 2005 US$) of Services in 2003 to that in 2005?
Ensure brevity in your answer.  0.85. What is the ratio of the Value added (constant 2005 US$) in Agriculture in 2003 to that in 2005?
Ensure brevity in your answer.  0.91. What is the ratio of the Value added (constant 2005 US$) in Industry in 2003 to that in 2006?
Keep it short and to the point. 0.75. What is the ratio of the Value added (constant 2005 US$) in Services in 2003 to that in 2006?
Offer a very short reply. 0.79. What is the ratio of the Value added (constant 2005 US$) in Agriculture in 2003 to that in 2006?
Provide a succinct answer. 0.89. What is the ratio of the Value added (constant 2005 US$) in Industry in 2003 to that in 2007?
Offer a terse response. 0.7. What is the ratio of the Value added (constant 2005 US$) in Services in 2003 to that in 2007?
Offer a terse response. 0.73. What is the ratio of the Value added (constant 2005 US$) of Agriculture in 2003 to that in 2007?
Ensure brevity in your answer.  0.95. What is the ratio of the Value added (constant 2005 US$) of Industry in 2003 to that in 2008?
Provide a short and direct response. 0.69. What is the ratio of the Value added (constant 2005 US$) of Services in 2003 to that in 2008?
Your answer should be very brief. 0.7. What is the ratio of the Value added (constant 2005 US$) of Agriculture in 2003 to that in 2008?
Your answer should be compact. 0.88. What is the ratio of the Value added (constant 2005 US$) in Industry in 2003 to that in 2009?
Keep it short and to the point. 0.73. What is the ratio of the Value added (constant 2005 US$) of Services in 2003 to that in 2009?
Your response must be concise. 0.72. What is the ratio of the Value added (constant 2005 US$) in Agriculture in 2003 to that in 2009?
Your answer should be very brief. 0.87. What is the ratio of the Value added (constant 2005 US$) in Industry in 2003 to that in 2010?
Keep it short and to the point. 0.67. What is the ratio of the Value added (constant 2005 US$) in Services in 2003 to that in 2010?
Provide a succinct answer. 0.68. What is the ratio of the Value added (constant 2005 US$) in Agriculture in 2003 to that in 2010?
Provide a short and direct response. 0.85. What is the ratio of the Value added (constant 2005 US$) of Industry in 2004 to that in 2005?
Your answer should be very brief. 0.92. What is the ratio of the Value added (constant 2005 US$) of Services in 2004 to that in 2005?
Keep it short and to the point. 0.93. What is the ratio of the Value added (constant 2005 US$) in Agriculture in 2004 to that in 2005?
Provide a succinct answer. 0.97. What is the ratio of the Value added (constant 2005 US$) of Industry in 2004 to that in 2006?
Offer a terse response. 0.83. What is the ratio of the Value added (constant 2005 US$) of Services in 2004 to that in 2006?
Make the answer very short. 0.86. What is the ratio of the Value added (constant 2005 US$) in Agriculture in 2004 to that in 2006?
Make the answer very short. 0.95. What is the ratio of the Value added (constant 2005 US$) in Industry in 2004 to that in 2007?
Offer a very short reply. 0.77. What is the ratio of the Value added (constant 2005 US$) in Services in 2004 to that in 2007?
Offer a terse response. 0.79. What is the ratio of the Value added (constant 2005 US$) of Agriculture in 2004 to that in 2007?
Ensure brevity in your answer.  1.02. What is the ratio of the Value added (constant 2005 US$) in Industry in 2004 to that in 2008?
Provide a short and direct response. 0.76. What is the ratio of the Value added (constant 2005 US$) of Services in 2004 to that in 2008?
Provide a short and direct response. 0.76. What is the ratio of the Value added (constant 2005 US$) in Agriculture in 2004 to that in 2008?
Your answer should be compact. 0.95. What is the ratio of the Value added (constant 2005 US$) in Industry in 2004 to that in 2009?
Your response must be concise. 0.81. What is the ratio of the Value added (constant 2005 US$) of Services in 2004 to that in 2009?
Your answer should be compact. 0.79. What is the ratio of the Value added (constant 2005 US$) of Agriculture in 2004 to that in 2009?
Ensure brevity in your answer.  0.93. What is the ratio of the Value added (constant 2005 US$) in Industry in 2004 to that in 2010?
Provide a succinct answer. 0.74. What is the ratio of the Value added (constant 2005 US$) in Services in 2004 to that in 2010?
Offer a terse response. 0.75. What is the ratio of the Value added (constant 2005 US$) in Agriculture in 2004 to that in 2010?
Offer a very short reply. 0.92. What is the ratio of the Value added (constant 2005 US$) in Industry in 2005 to that in 2006?
Provide a succinct answer. 0.9. What is the ratio of the Value added (constant 2005 US$) of Services in 2005 to that in 2006?
Keep it short and to the point. 0.93. What is the ratio of the Value added (constant 2005 US$) of Agriculture in 2005 to that in 2006?
Offer a terse response. 0.98. What is the ratio of the Value added (constant 2005 US$) of Industry in 2005 to that in 2007?
Your answer should be compact. 0.84. What is the ratio of the Value added (constant 2005 US$) of Services in 2005 to that in 2007?
Provide a short and direct response. 0.85. What is the ratio of the Value added (constant 2005 US$) of Agriculture in 2005 to that in 2007?
Your answer should be very brief. 1.05. What is the ratio of the Value added (constant 2005 US$) of Industry in 2005 to that in 2008?
Your answer should be very brief. 0.82. What is the ratio of the Value added (constant 2005 US$) of Services in 2005 to that in 2008?
Provide a succinct answer. 0.82. What is the ratio of the Value added (constant 2005 US$) of Agriculture in 2005 to that in 2008?
Provide a short and direct response. 0.97. What is the ratio of the Value added (constant 2005 US$) of Industry in 2005 to that in 2009?
Make the answer very short. 0.88. What is the ratio of the Value added (constant 2005 US$) in Services in 2005 to that in 2009?
Keep it short and to the point. 0.85. What is the ratio of the Value added (constant 2005 US$) of Agriculture in 2005 to that in 2009?
Your answer should be compact. 0.96. What is the ratio of the Value added (constant 2005 US$) in Industry in 2005 to that in 2010?
Offer a terse response. 0.8. What is the ratio of the Value added (constant 2005 US$) of Services in 2005 to that in 2010?
Offer a terse response. 0.8. What is the ratio of the Value added (constant 2005 US$) of Agriculture in 2005 to that in 2010?
Keep it short and to the point. 0.94. What is the ratio of the Value added (constant 2005 US$) of Industry in 2006 to that in 2007?
Offer a terse response. 0.93. What is the ratio of the Value added (constant 2005 US$) of Services in 2006 to that in 2007?
Offer a very short reply. 0.92. What is the ratio of the Value added (constant 2005 US$) in Agriculture in 2006 to that in 2007?
Keep it short and to the point. 1.07. What is the ratio of the Value added (constant 2005 US$) of Industry in 2006 to that in 2008?
Offer a very short reply. 0.92. What is the ratio of the Value added (constant 2005 US$) of Services in 2006 to that in 2008?
Keep it short and to the point. 0.88. What is the ratio of the Value added (constant 2005 US$) of Agriculture in 2006 to that in 2008?
Provide a succinct answer. 0.99. What is the ratio of the Value added (constant 2005 US$) of Industry in 2006 to that in 2009?
Ensure brevity in your answer.  0.98. What is the ratio of the Value added (constant 2005 US$) in Services in 2006 to that in 2009?
Offer a very short reply. 0.91. What is the ratio of the Value added (constant 2005 US$) of Agriculture in 2006 to that in 2009?
Offer a terse response. 0.98. What is the ratio of the Value added (constant 2005 US$) in Industry in 2006 to that in 2010?
Your answer should be very brief. 0.89. What is the ratio of the Value added (constant 2005 US$) in Services in 2006 to that in 2010?
Your answer should be very brief. 0.87. What is the ratio of the Value added (constant 2005 US$) in Agriculture in 2006 to that in 2010?
Offer a very short reply. 0.96. What is the ratio of the Value added (constant 2005 US$) of Industry in 2007 to that in 2008?
Make the answer very short. 0.99. What is the ratio of the Value added (constant 2005 US$) in Services in 2007 to that in 2008?
Your response must be concise. 0.96. What is the ratio of the Value added (constant 2005 US$) in Agriculture in 2007 to that in 2008?
Keep it short and to the point. 0.93. What is the ratio of the Value added (constant 2005 US$) of Industry in 2007 to that in 2009?
Keep it short and to the point. 1.05. What is the ratio of the Value added (constant 2005 US$) of Services in 2007 to that in 2009?
Give a very brief answer. 0.99. What is the ratio of the Value added (constant 2005 US$) of Agriculture in 2007 to that in 2009?
Ensure brevity in your answer.  0.91. What is the ratio of the Value added (constant 2005 US$) of Industry in 2007 to that in 2010?
Offer a very short reply. 0.96. What is the ratio of the Value added (constant 2005 US$) in Services in 2007 to that in 2010?
Keep it short and to the point. 0.94. What is the ratio of the Value added (constant 2005 US$) in Agriculture in 2007 to that in 2010?
Your response must be concise. 0.9. What is the ratio of the Value added (constant 2005 US$) of Industry in 2008 to that in 2009?
Provide a succinct answer. 1.06. What is the ratio of the Value added (constant 2005 US$) of Services in 2008 to that in 2009?
Your answer should be compact. 1.03. What is the ratio of the Value added (constant 2005 US$) of Agriculture in 2008 to that in 2009?
Provide a short and direct response. 0.98. What is the ratio of the Value added (constant 2005 US$) in Industry in 2008 to that in 2010?
Make the answer very short. 0.97. What is the ratio of the Value added (constant 2005 US$) in Services in 2008 to that in 2010?
Ensure brevity in your answer.  0.98. What is the ratio of the Value added (constant 2005 US$) of Industry in 2009 to that in 2010?
Offer a terse response. 0.91. What is the ratio of the Value added (constant 2005 US$) of Services in 2009 to that in 2010?
Offer a terse response. 0.95. What is the ratio of the Value added (constant 2005 US$) in Agriculture in 2009 to that in 2010?
Make the answer very short. 0.98. What is the difference between the highest and the second highest Value added (constant 2005 US$) in Industry?
Make the answer very short. 8.87e+09. What is the difference between the highest and the second highest Value added (constant 2005 US$) of Services?
Provide a succinct answer. 1.11e+1. What is the difference between the highest and the second highest Value added (constant 2005 US$) in Agriculture?
Your answer should be compact. 1.54e+09. What is the difference between the highest and the lowest Value added (constant 2005 US$) of Industry?
Your answer should be very brief. 1.14e+11. What is the difference between the highest and the lowest Value added (constant 2005 US$) in Services?
Make the answer very short. 2.01e+11. What is the difference between the highest and the lowest Value added (constant 2005 US$) in Agriculture?
Your answer should be compact. 1.33e+1. 